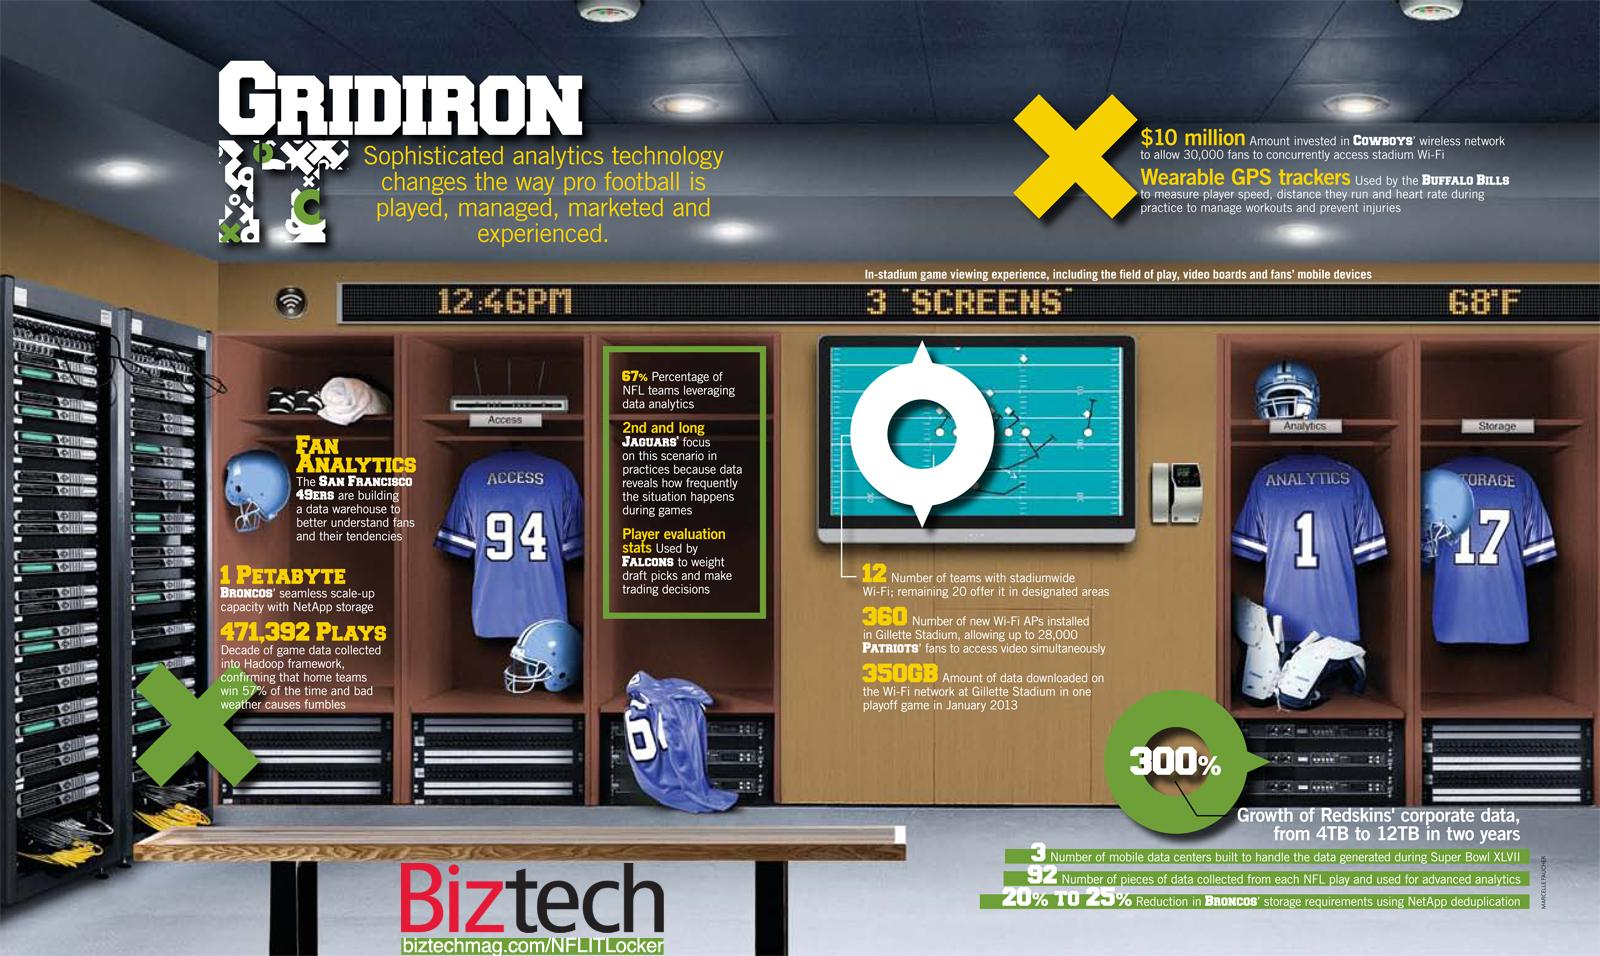Mention a couple of crucial points in this snapshot. The San Francisco 49ers are constructing a data warehouse to gain insight into the behavior and preferences of their fans. In order to select optimal draft picks and engage in strategic trades, player evaluation statistics are relied upon as the primary decision-making tool. 